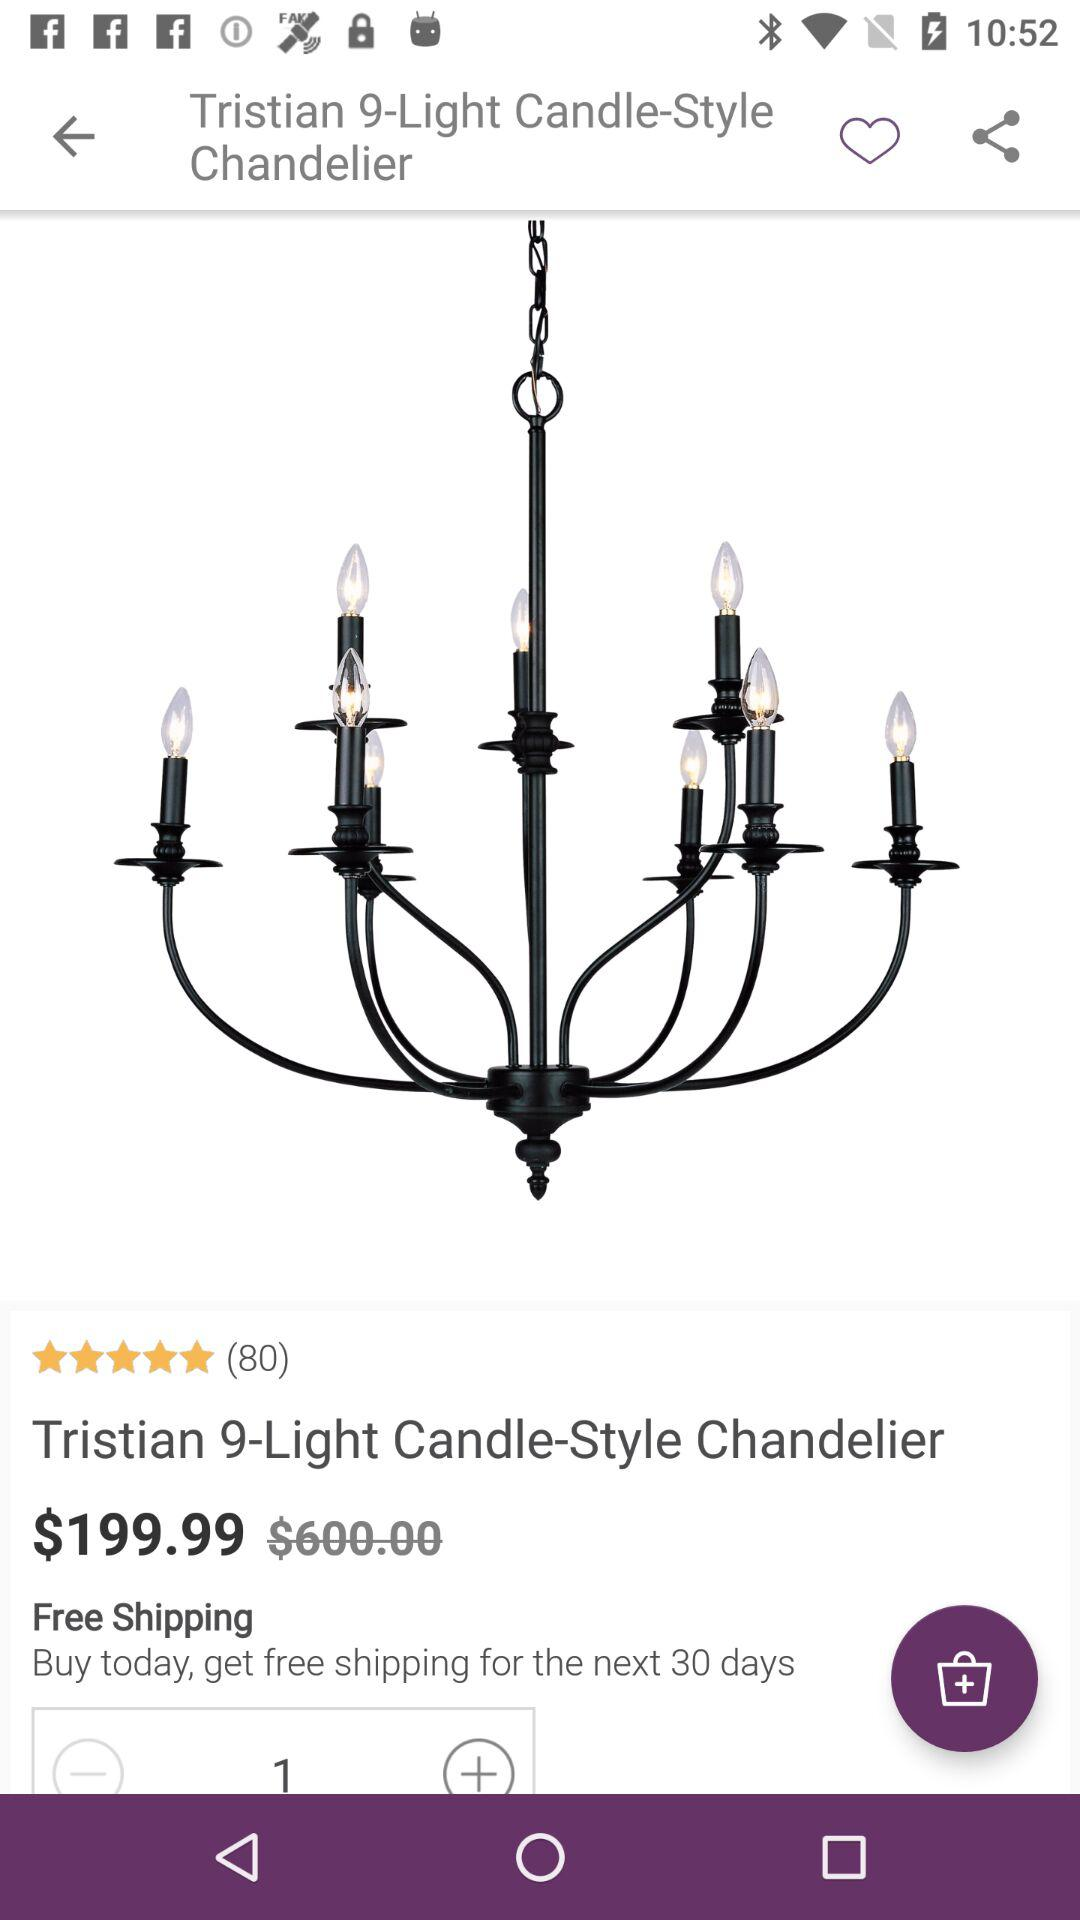What is the original price of the product? The original price of the product is $600. 